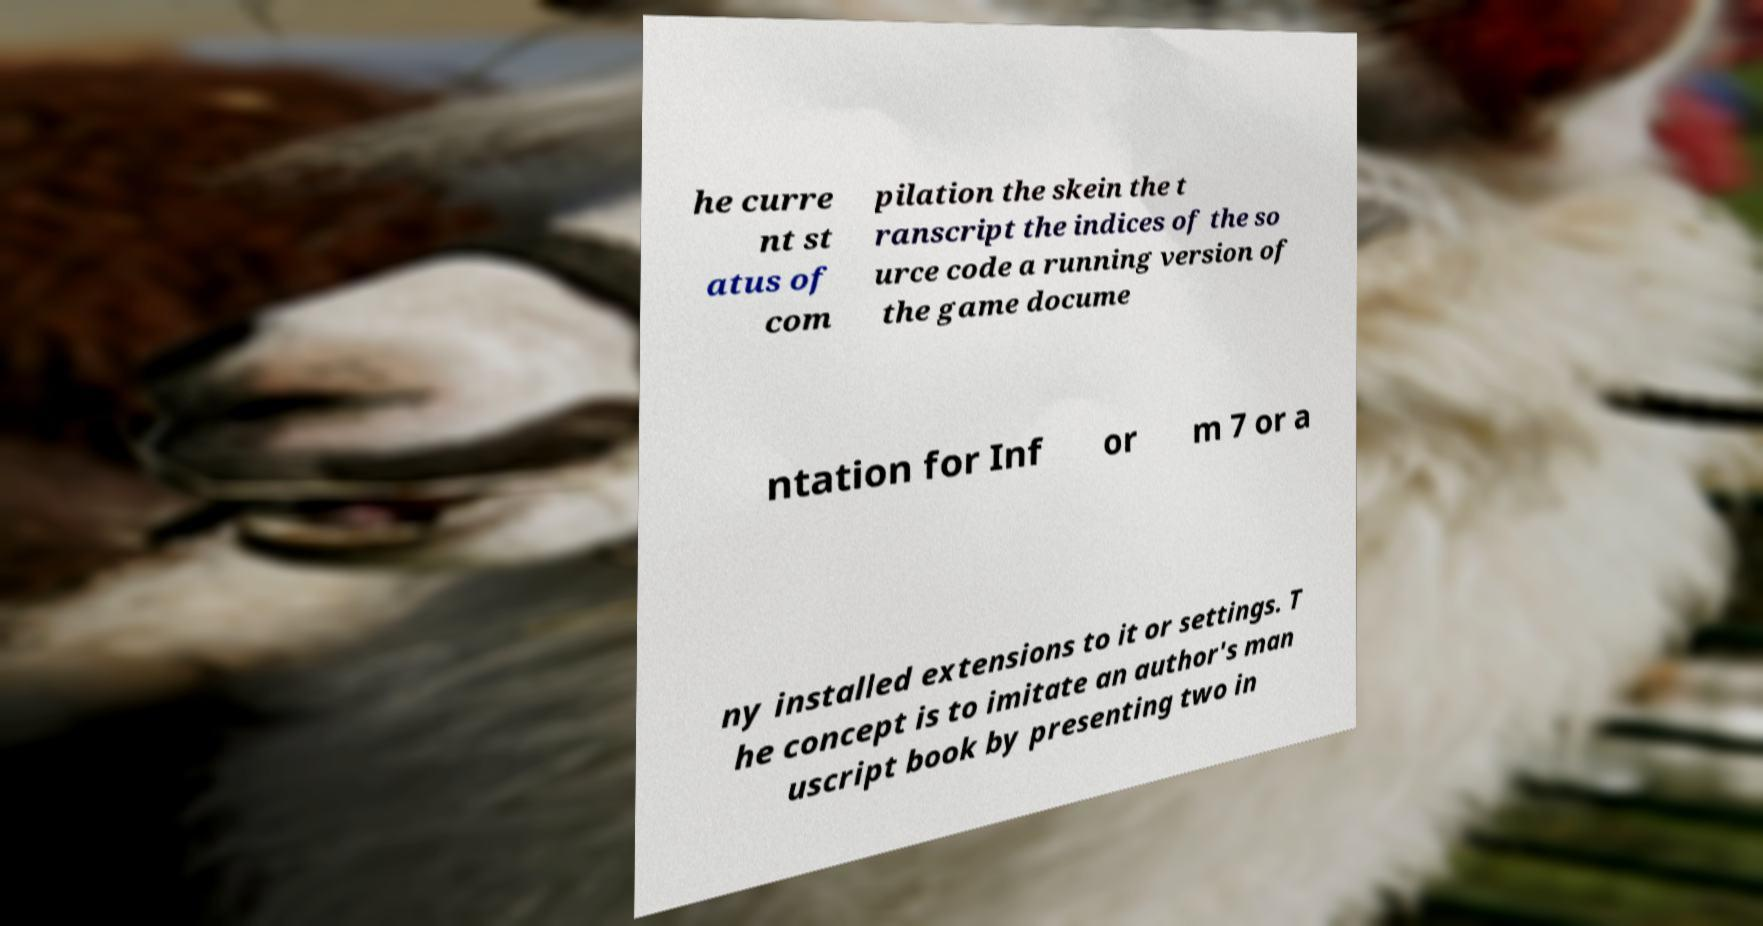Please read and relay the text visible in this image. What does it say? he curre nt st atus of com pilation the skein the t ranscript the indices of the so urce code a running version of the game docume ntation for Inf or m 7 or a ny installed extensions to it or settings. T he concept is to imitate an author's man uscript book by presenting two in 